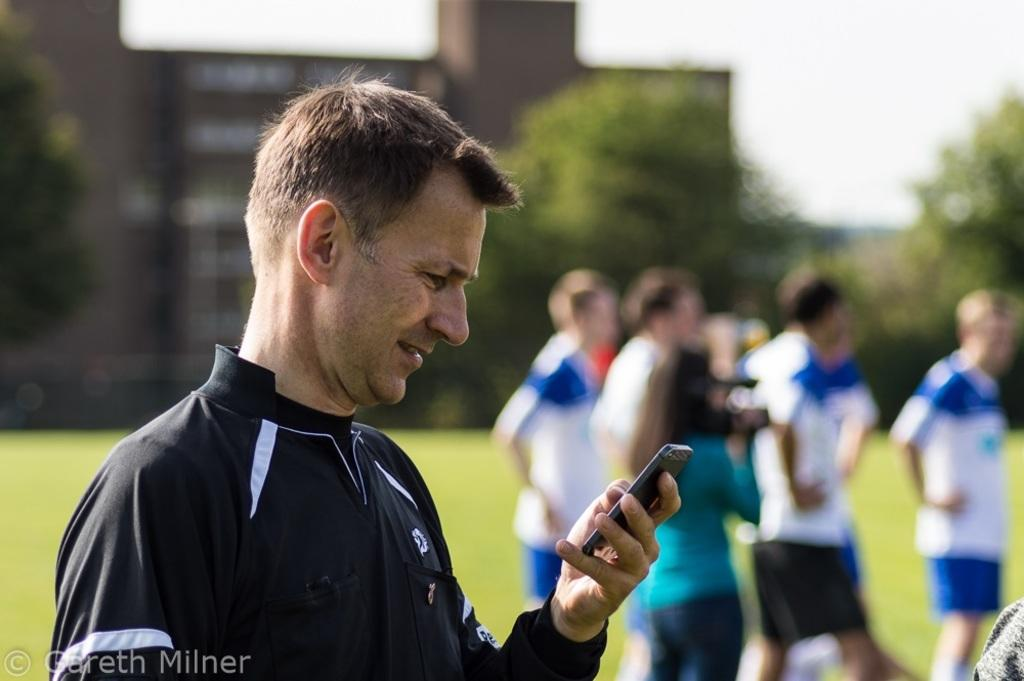Who is present in the image? There is a man in the image. What is the man looking at? The man is looking at a mobile. What is the man's facial expression? The man is smiling. What can be seen in the background of the image? There is a group of people walking, a building, trees, and the sky visible in the background. What type of doll is sitting on the vessel in the image? There is no doll or vessel present in the image. What kind of flower is growing near the man in the image? There is no flower visible near the man in the image. 